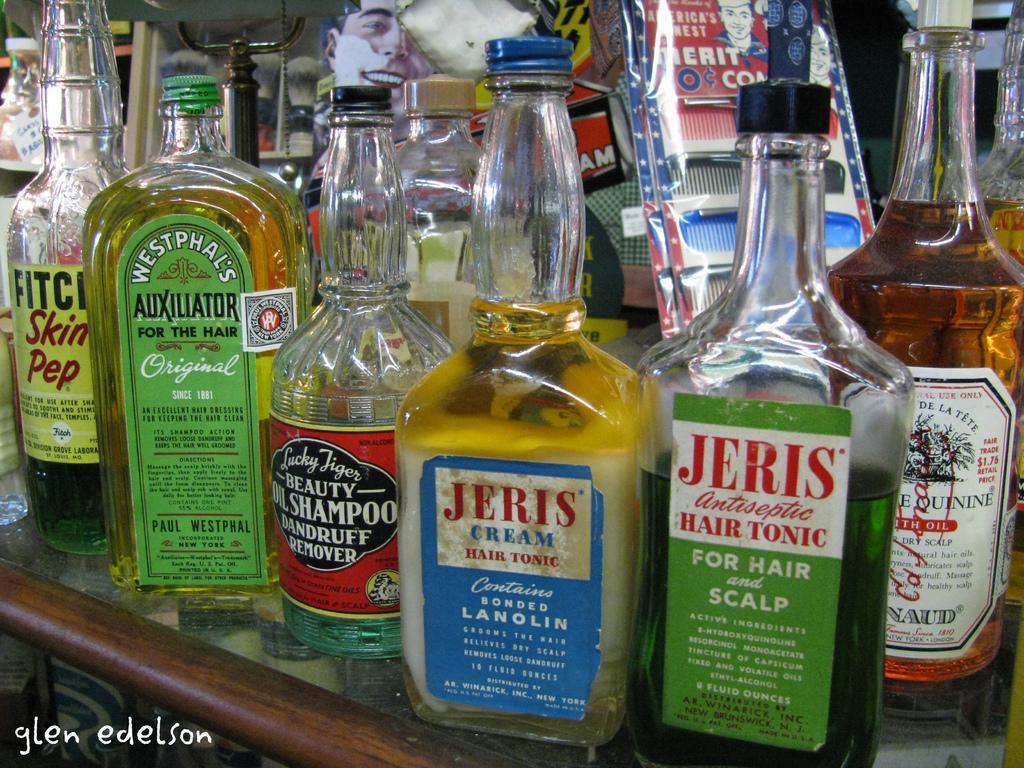Describe this image in one or two sentences. There are different types of bottles placed in the shelf in this picture. 